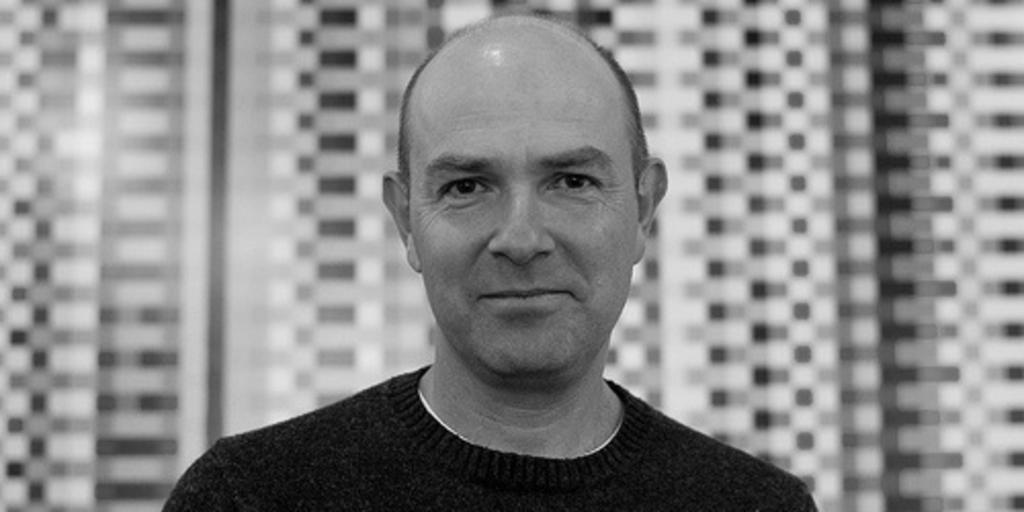What is the color scheme of the image? The image is black and white. Can you describe the main subject in the image? There is a person in the image. What can be said about the background of the image? The background of the image is blurry. Where is the playground located in the image? There is no playground present in the image. What color is the orange in the image? There is no orange present in the image, as it is a black and white image. 